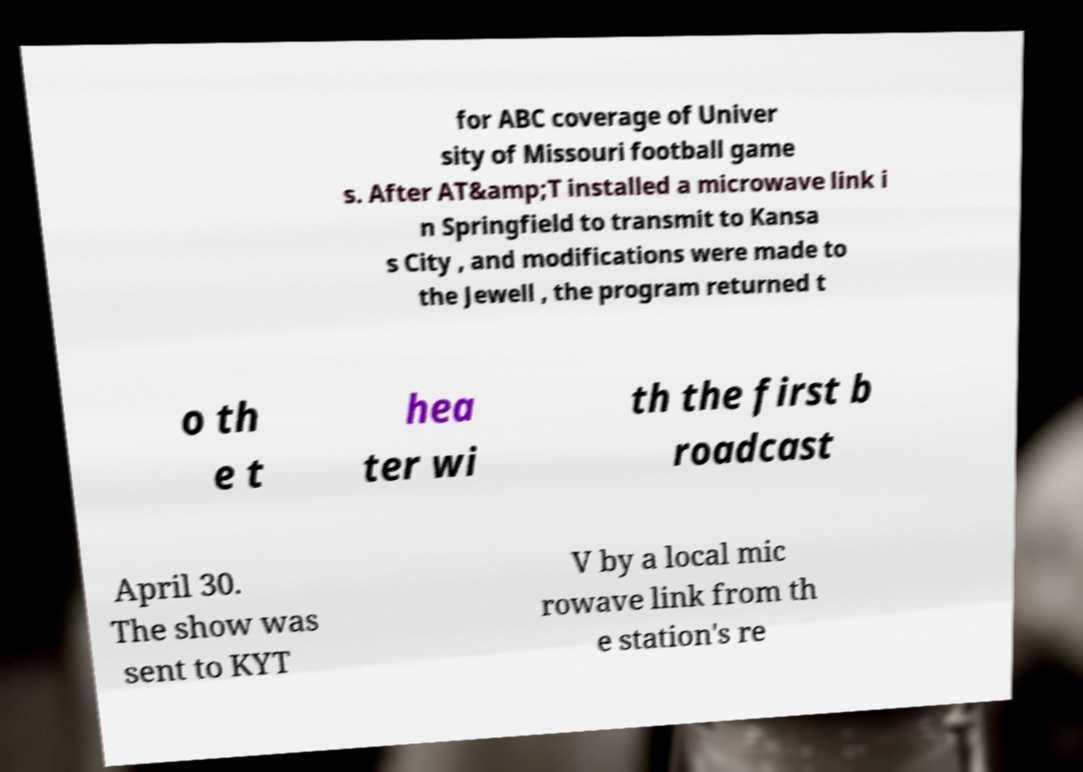Can you read and provide the text displayed in the image?This photo seems to have some interesting text. Can you extract and type it out for me? for ABC coverage of Univer sity of Missouri football game s. After AT&amp;T installed a microwave link i n Springfield to transmit to Kansa s City , and modifications were made to the Jewell , the program returned t o th e t hea ter wi th the first b roadcast April 30. The show was sent to KYT V by a local mic rowave link from th e station's re 